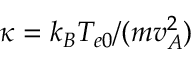<formula> <loc_0><loc_0><loc_500><loc_500>\kappa = k _ { B } T _ { e 0 } / ( m v _ { A } ^ { 2 } )</formula> 